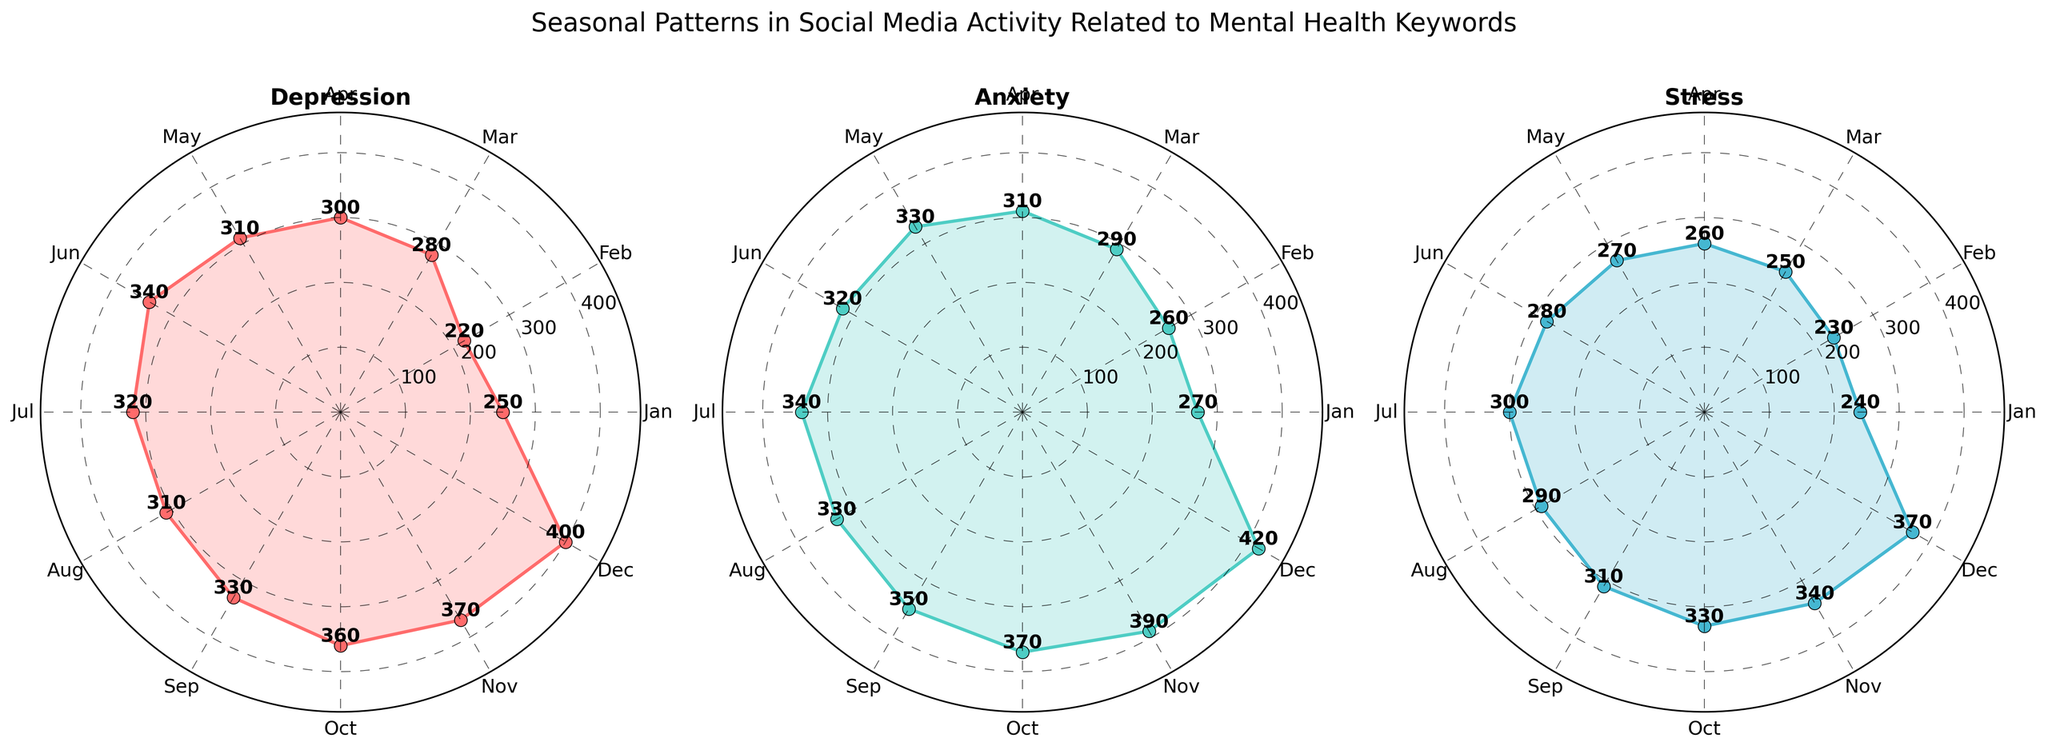What is the title of the plot? The title is located at the top center of the figure and indicates the main subject of the plot. It is written in larger, bold font for emphasis.
Answer: Seasonal Patterns in Social Media Activity Related to Mental Health Keywords What are the three categories displayed? The categories are indicated at the top of each subplot. Each subplot is labeled with a category name.
Answer: Depression, Anxiety, Stress Which month has the highest count for 'Depression'? In the 'Depression' subplot, the highest point on the radial axis corresponds to December. The numeric count next to the plot line in December confirms this.
Answer: December What is the average count for 'Stress' across all months? Add the counts for all months in the 'Stress' subplot (240+230+250+260+270+280+300+290+310+330+340+370) and divide by 12 (number of months). (240+230+250+260+270+280+300+290+310+330+340+370 = 3770, then 3770/12 = 314.17)
Answer: 314.17 During which month does 'Anxiety' have a count of 310? Follow the line in the 'Anxiety' subplot and locate the month where it touches the 310 radial mark. The numeric count near the plot line in April confirms this.
Answer: April Which category shows the highest overall count in any single month? Compare the highest peaks in each subplot. By referring to the December data points, note that 'Anxiety' reaches the highest count at 420.
Answer: Anxiety How does the count for 'Stress' in October compare to 'Depression' in the same month? Look at the data points for October in both 'Stress' and 'Depression' subplots. Stress is at 330, while Depression is at 360.
Answer: Depression is higher What is the increase in 'Depression' count from January to December? Subtract the January count from the December count in the 'Depression' subplot. (400 - 250 = 150)
Answer: 150 Which month shows the lowest activity for 'Stress'? Identify the smallest count value in the 'Stress' subplot. The smallest count of 230 is in February.
Answer: February What trend is observable for 'Anxiety' from June to December? Describe the pattern of the 'Anxiety' count values between these months in the subplot. The trend shows a general increase from 320 in June to 420 in December.
Answer: Increasing trend 